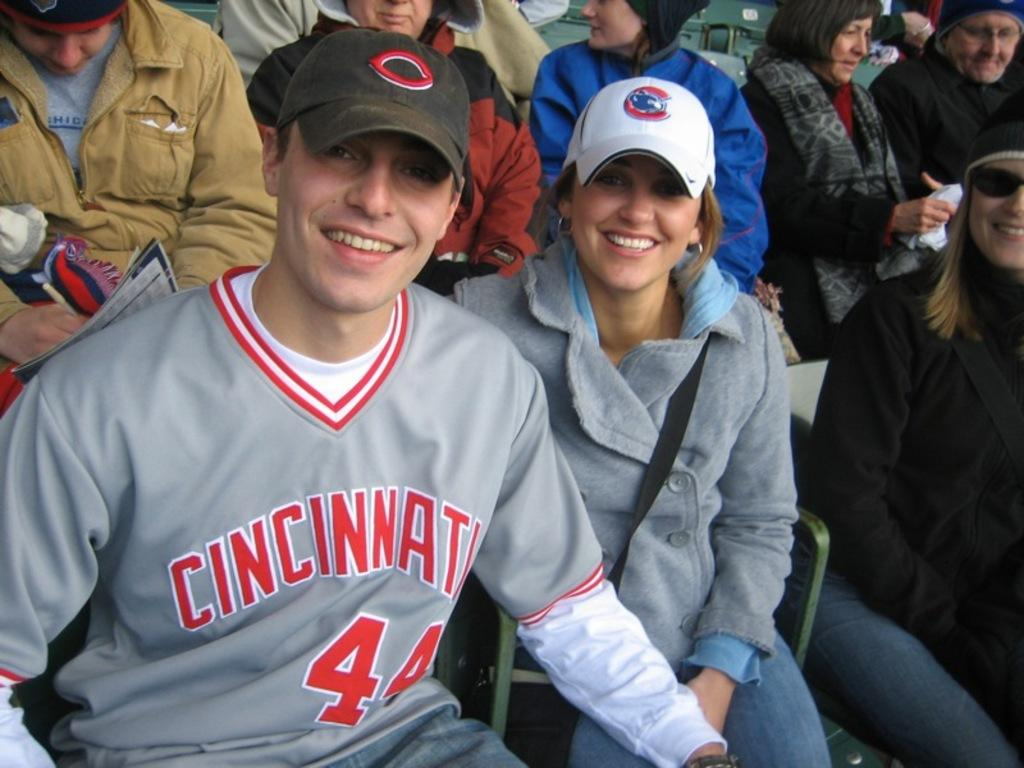<image>
Describe the image concisely. A man with the letter c on his shirt is sitting with a woman. 